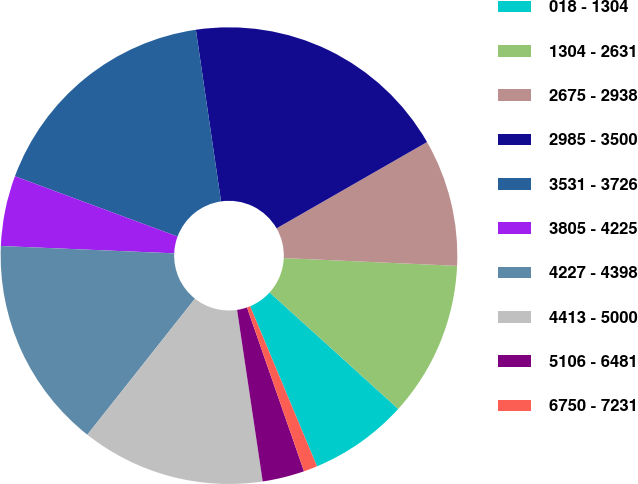Convert chart to OTSL. <chart><loc_0><loc_0><loc_500><loc_500><pie_chart><fcel>018 - 1304<fcel>1304 - 2631<fcel>2675 - 2938<fcel>2985 - 3500<fcel>3531 - 3726<fcel>3805 - 4225<fcel>4227 - 4398<fcel>4413 - 5000<fcel>5106 - 6481<fcel>6750 - 7231<nl><fcel>6.99%<fcel>11.0%<fcel>9.0%<fcel>19.03%<fcel>17.03%<fcel>4.98%<fcel>15.02%<fcel>13.01%<fcel>2.97%<fcel>0.97%<nl></chart> 